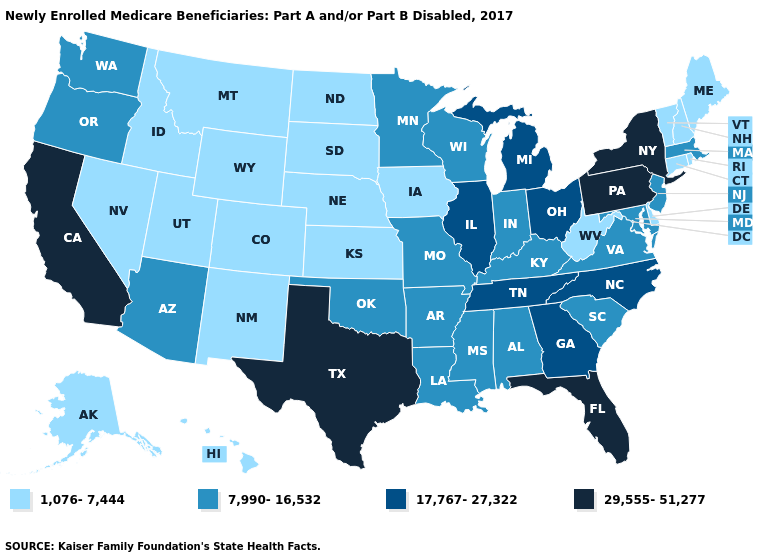Name the states that have a value in the range 1,076-7,444?
Give a very brief answer. Alaska, Colorado, Connecticut, Delaware, Hawaii, Idaho, Iowa, Kansas, Maine, Montana, Nebraska, Nevada, New Hampshire, New Mexico, North Dakota, Rhode Island, South Dakota, Utah, Vermont, West Virginia, Wyoming. Does Alabama have a lower value than Pennsylvania?
Concise answer only. Yes. Does Vermont have a lower value than Nevada?
Give a very brief answer. No. Among the states that border Colorado , which have the lowest value?
Concise answer only. Kansas, Nebraska, New Mexico, Utah, Wyoming. Name the states that have a value in the range 7,990-16,532?
Write a very short answer. Alabama, Arizona, Arkansas, Indiana, Kentucky, Louisiana, Maryland, Massachusetts, Minnesota, Mississippi, Missouri, New Jersey, Oklahoma, Oregon, South Carolina, Virginia, Washington, Wisconsin. Name the states that have a value in the range 29,555-51,277?
Write a very short answer. California, Florida, New York, Pennsylvania, Texas. Among the states that border Arizona , which have the highest value?
Keep it brief. California. Name the states that have a value in the range 17,767-27,322?
Give a very brief answer. Georgia, Illinois, Michigan, North Carolina, Ohio, Tennessee. Does Louisiana have the same value as Maryland?
Give a very brief answer. Yes. Name the states that have a value in the range 29,555-51,277?
Be succinct. California, Florida, New York, Pennsylvania, Texas. What is the lowest value in states that border South Carolina?
Concise answer only. 17,767-27,322. Name the states that have a value in the range 29,555-51,277?
Be succinct. California, Florida, New York, Pennsylvania, Texas. Among the states that border Indiana , which have the highest value?
Be succinct. Illinois, Michigan, Ohio. What is the value of West Virginia?
Concise answer only. 1,076-7,444. What is the value of Ohio?
Short answer required. 17,767-27,322. 